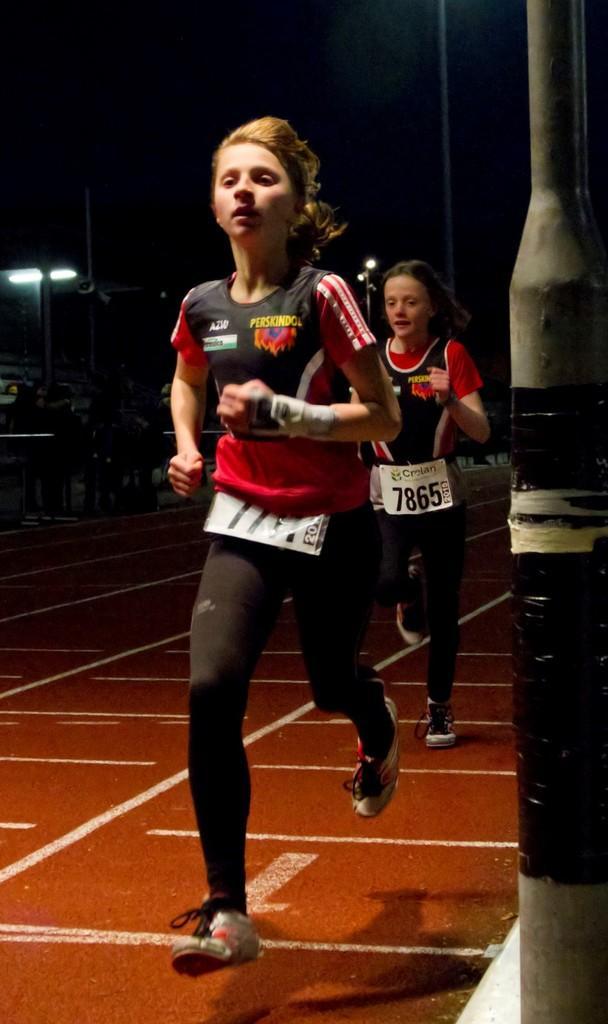Please provide a concise description of this image. In this picture we can see 2 girls running on the ground. 